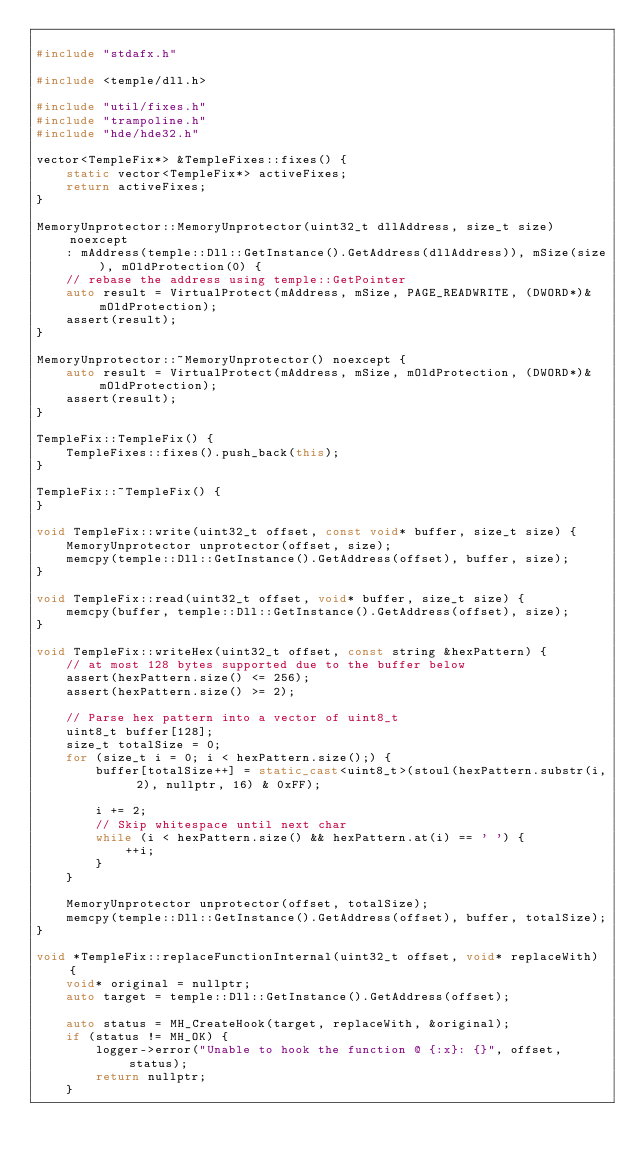Convert code to text. <code><loc_0><loc_0><loc_500><loc_500><_C++_>
#include "stdafx.h"

#include <temple/dll.h>

#include "util/fixes.h"
#include "trampoline.h"
#include "hde/hde32.h"

vector<TempleFix*> &TempleFixes::fixes() {
	static vector<TempleFix*> activeFixes;
	return activeFixes;
}

MemoryUnprotector::MemoryUnprotector(uint32_t dllAddress, size_t size) noexcept
	: mAddress(temple::Dll::GetInstance().GetAddress(dllAddress)), mSize(size), mOldProtection(0) {
	// rebase the address using temple::GetPointer
	auto result = VirtualProtect(mAddress, mSize, PAGE_READWRITE, (DWORD*)&mOldProtection);
	assert(result);
}

MemoryUnprotector::~MemoryUnprotector() noexcept {
	auto result = VirtualProtect(mAddress, mSize, mOldProtection, (DWORD*)&mOldProtection);
	assert(result);
}

TempleFix::TempleFix() {
	TempleFixes::fixes().push_back(this);
}

TempleFix::~TempleFix() {
}

void TempleFix::write(uint32_t offset, const void* buffer, size_t size) {
	MemoryUnprotector unprotector(offset, size);
	memcpy(temple::Dll::GetInstance().GetAddress(offset), buffer, size);
}

void TempleFix::read(uint32_t offset, void* buffer, size_t size) {
	memcpy(buffer, temple::Dll::GetInstance().GetAddress(offset), size);
}

void TempleFix::writeHex(uint32_t offset, const string &hexPattern) {
	// at most 128 bytes supported due to the buffer below
	assert(hexPattern.size() <= 256);
	assert(hexPattern.size() >= 2);

	// Parse hex pattern into a vector of uint8_t
	uint8_t buffer[128];
	size_t totalSize = 0;
	for (size_t i = 0; i < hexPattern.size();) {
		buffer[totalSize++] = static_cast<uint8_t>(stoul(hexPattern.substr(i, 2), nullptr, 16) & 0xFF);

		i += 2;
		// Skip whitespace until next char
		while (i < hexPattern.size() && hexPattern.at(i) == ' ') {
			++i;
		}
	}

	MemoryUnprotector unprotector(offset, totalSize);
	memcpy(temple::Dll::GetInstance().GetAddress(offset), buffer, totalSize);
}

void *TempleFix::replaceFunctionInternal(uint32_t offset, void* replaceWith) {
	void* original = nullptr;
	auto target = temple::Dll::GetInstance().GetAddress(offset);
	
	auto status = MH_CreateHook(target, replaceWith, &original);
	if (status != MH_OK) {
		logger->error("Unable to hook the function @ {:x}: {}", offset, status);
		return nullptr;
	}
</code> 